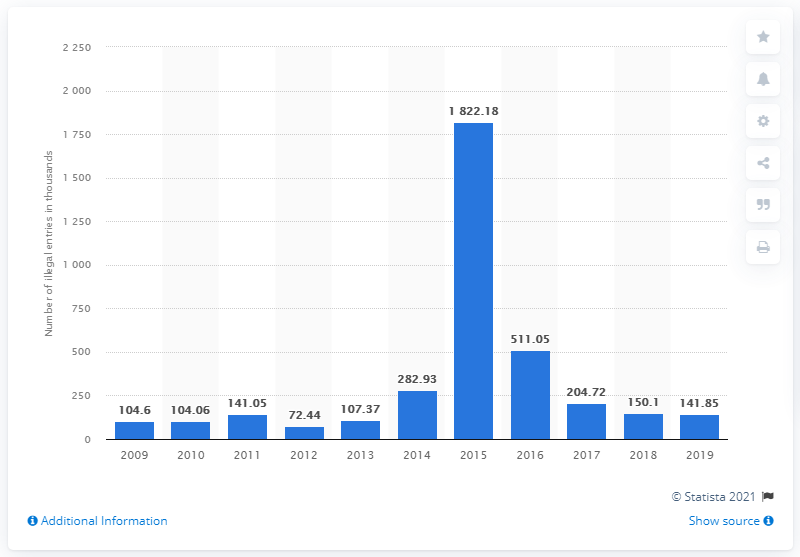Specify some key components in this picture. Illegal border crossings peaked in 2015. 